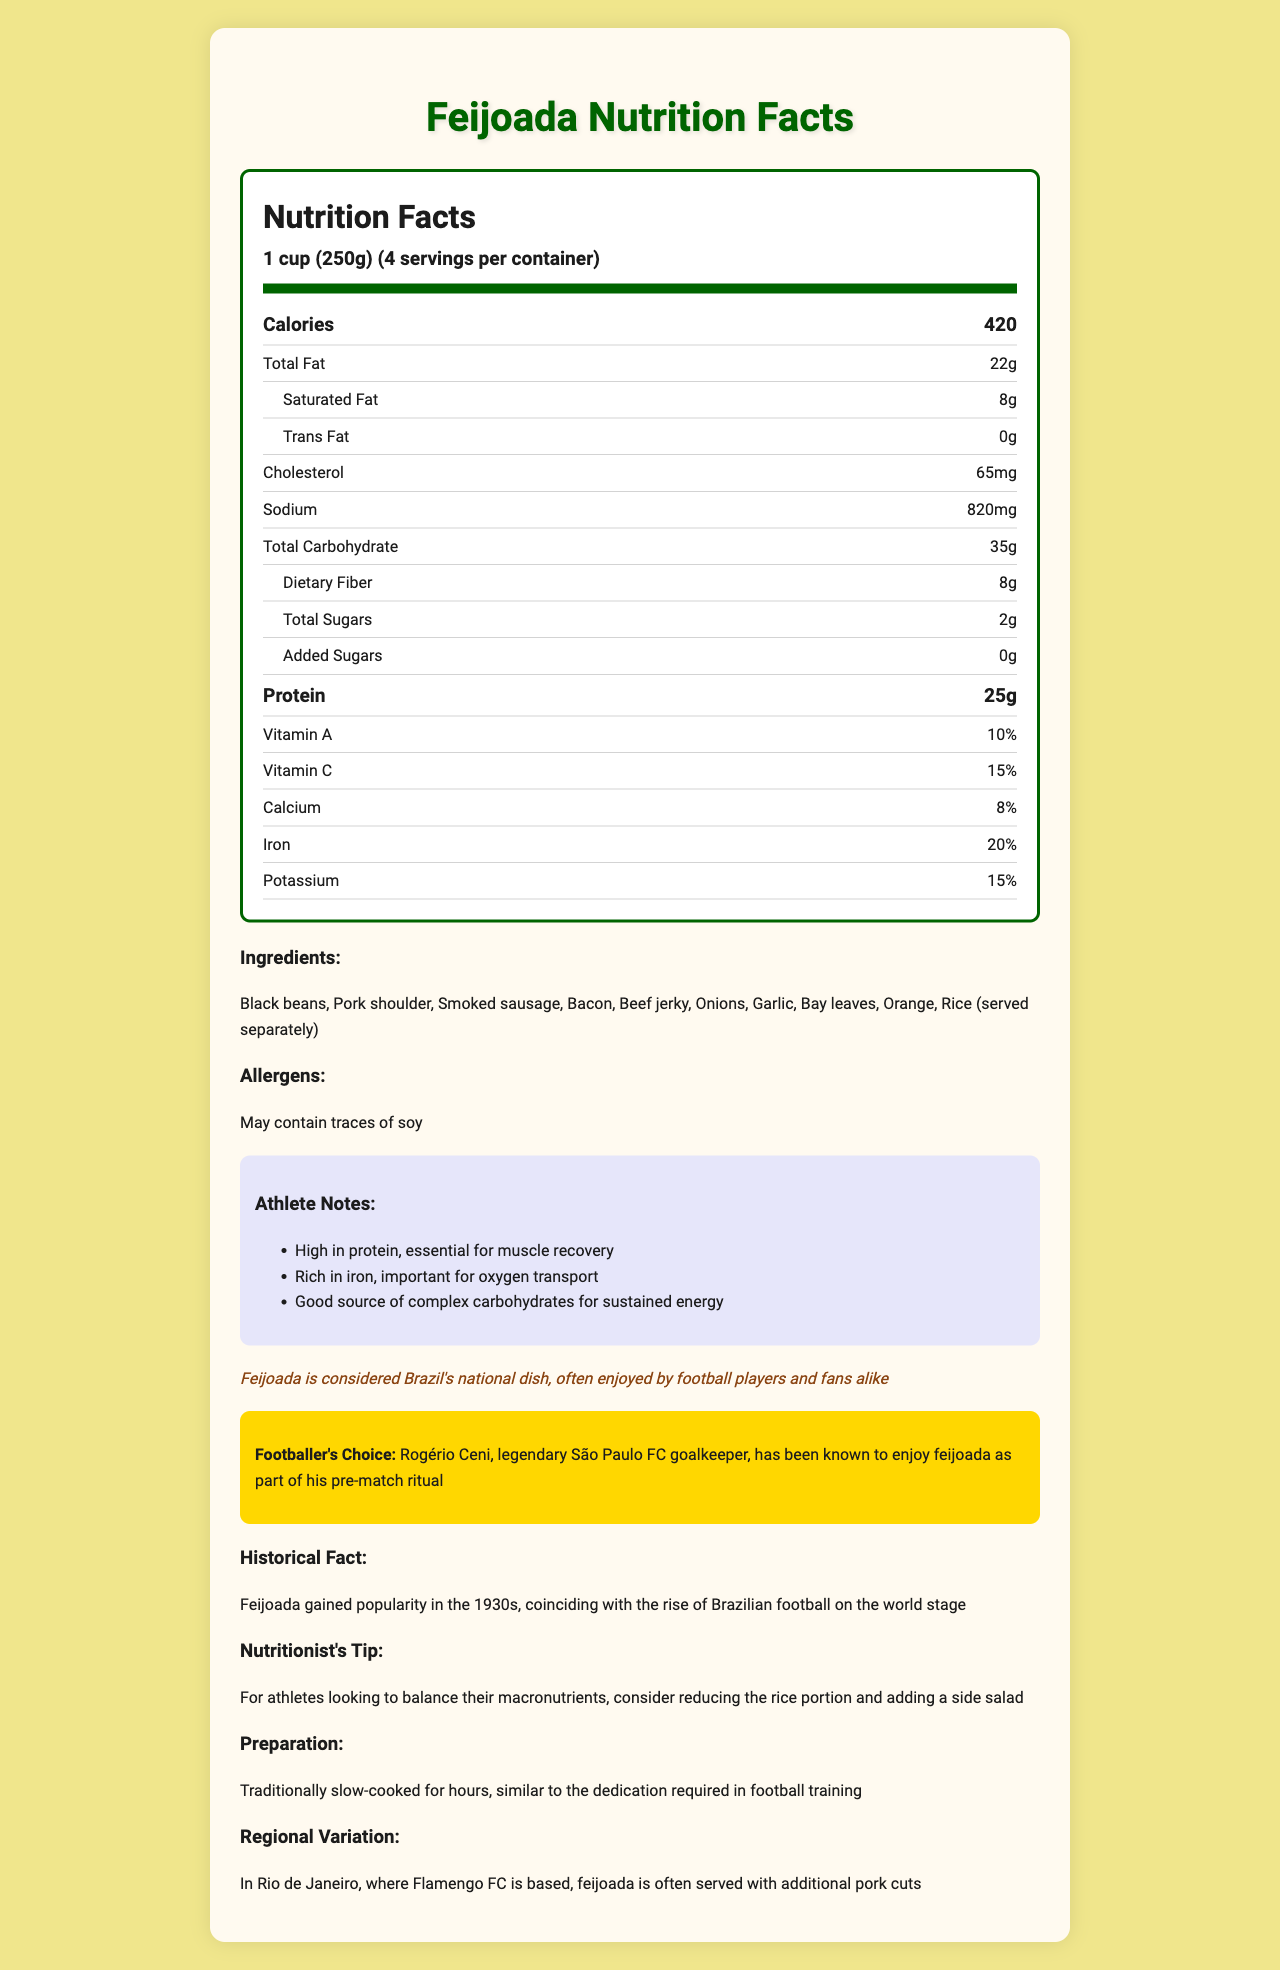what is the serving size for the feijoada? The serving size is clearly indicated in the nutrition label part of the document.
Answer: 1 cup (250g) how many calories are in one serving of feijoada? As per the nutrition label, each serving contains 420 calories.
Answer: 420 what is the total protein content per serving? The nutrition label specifies that each serving contains 25 grams of protein.
Answer: 25g how much dietary fiber does one serving of feijoada provide? The document states that each serving contains 8 grams of dietary fiber.
Answer: 8g list three ingredients found in feijoada. The ingredients are listed under the "Ingredients" section in the document.
Answer: Black beans, Pork shoulder, Rice (served separately) which of the following nutrients is highest in percentage of daily value per serving? A. Vitamin C B. Calcium C. Iron D. Vitamin A Iron has a daily value percentage of 20%, the highest among the nutrients listed in the document.
Answer: C who is the famous footballer associated with feijoada in the document? A. Pelé B. Neymar C. Rogério Ceni D. Zico Rogério Ceni is mentioned as the footballer who enjoys feijoada as part of his pre-match ritual.
Answer: C is feijoada considered Brazil's national dish? The document mentions that feijoada is considered Brazil's national dish.
Answer: Yes describe the main point of the document. The document not only provides comprehensive nutritional information but also ties in cultural context, athlete-specific notes, and preparation methods.
Answer: It details the nutritional facts, cultural significance, athlete benefits, and preparation methods of the traditional Brazilian feijoada meal. what is the exact ingredient list of the feijoada? The document lists the ingredients but does not specify quantities or the exact proportions for each ingredient.
Answer: Not enough information why is feijoada recommended for athletes? The "Athlete Notes" section explains why feijoada is beneficial for athletes, highlighting its high protein content, iron, and complex carbohydrates.
Answer: High in protein for muscle recovery, rich in iron for oxygen transport, and a good source of complex carbohydrates for energy. 